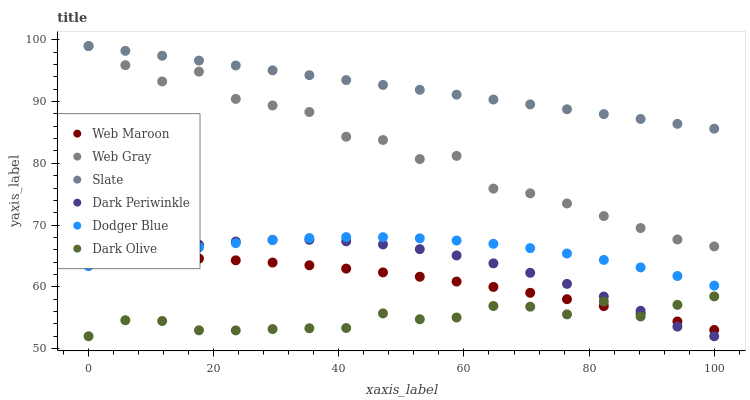Does Dark Olive have the minimum area under the curve?
Answer yes or no. Yes. Does Slate have the maximum area under the curve?
Answer yes or no. Yes. Does Slate have the minimum area under the curve?
Answer yes or no. No. Does Dark Olive have the maximum area under the curve?
Answer yes or no. No. Is Slate the smoothest?
Answer yes or no. Yes. Is Web Gray the roughest?
Answer yes or no. Yes. Is Dark Olive the smoothest?
Answer yes or no. No. Is Dark Olive the roughest?
Answer yes or no. No. Does Dark Olive have the lowest value?
Answer yes or no. Yes. Does Slate have the lowest value?
Answer yes or no. No. Does Slate have the highest value?
Answer yes or no. Yes. Does Dark Olive have the highest value?
Answer yes or no. No. Is Dodger Blue less than Slate?
Answer yes or no. Yes. Is Dodger Blue greater than Dark Olive?
Answer yes or no. Yes. Does Web Gray intersect Slate?
Answer yes or no. Yes. Is Web Gray less than Slate?
Answer yes or no. No. Is Web Gray greater than Slate?
Answer yes or no. No. Does Dodger Blue intersect Slate?
Answer yes or no. No. 